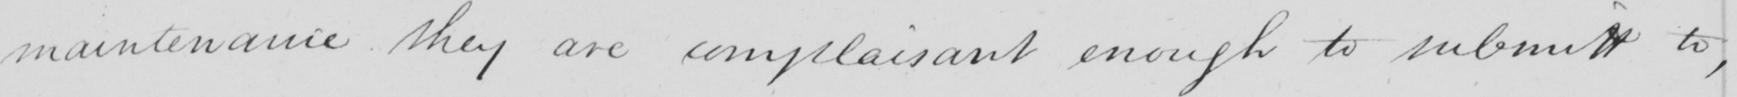Can you read and transcribe this handwriting? maintenance they are complaisant enough to submitt to , 